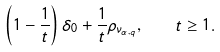Convert formula to latex. <formula><loc_0><loc_0><loc_500><loc_500>\left ( 1 - \frac { 1 } { t } \right ) \delta _ { 0 } + \frac { 1 } { t } \rho _ { \nu _ { \alpha , q } } , \quad t \geq 1 .</formula> 